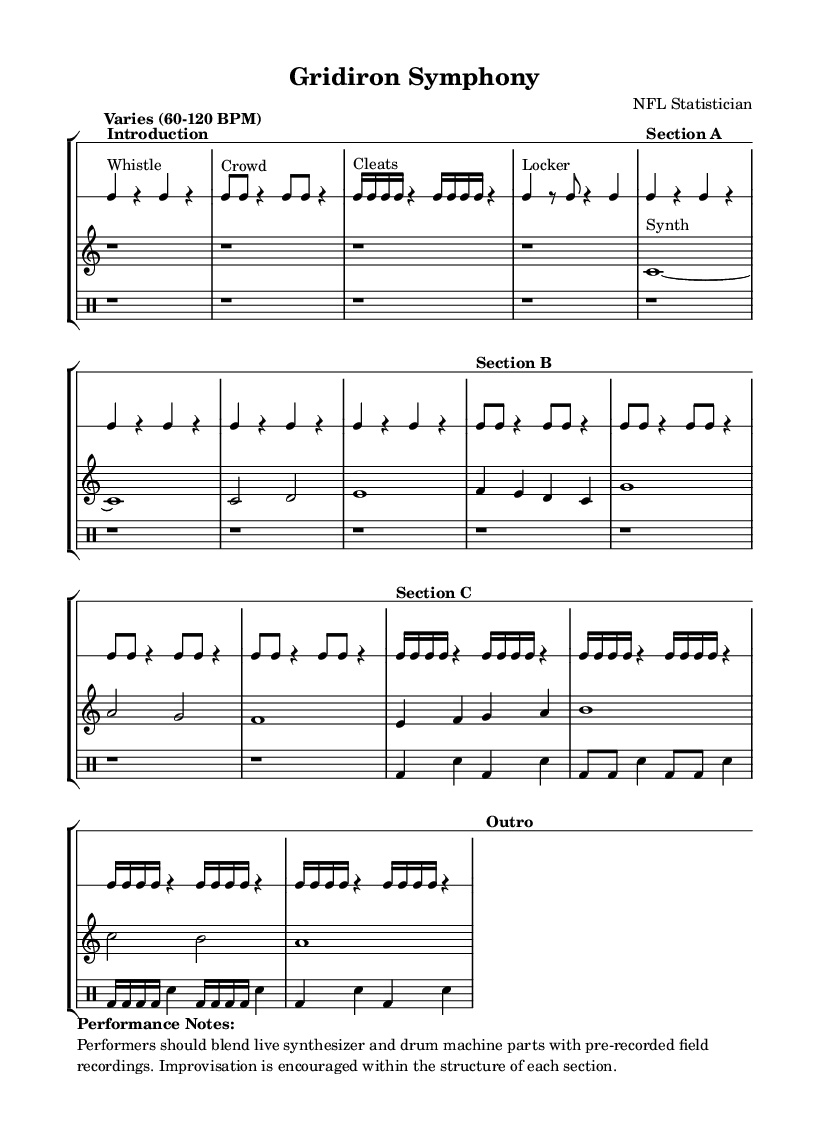What is the time signature of this piece? The time signature is indicated at the beginning of the rhythmic staff as 4/4. This means there are four beats in a measure, and each beat is a quarter note.
Answer: 4/4 What is the tempo range specified in the score? The tempo is marked as "Varies (60-120 BPM)," meaning the performance speed can fluctuate within that range. This flexibility reflects the experimental nature of the piece.
Answer: 60-120 BPM What sound is associated with the rhythmic staff's notes? The rhythmic staff includes specific sounds labeled as "Whistle," "Crowd," "Cleats," "Locker," and indications for drumming (bass drum and snare). These designations suggest the specific field recordings being imitated or incorporated.
Answer: Whistle, Crowd, Cleats, Locker How many distinct sections are indicated in the score? The score features five distinct sections labeled as "Introduction," "Section A," "Section B," "Section C," and "Outro." Each section contributes to the overall structure of the composition.
Answer: Five What type of instruments are indicated for the melodic staff? The melodic staff designates the sound of a synthesizer, indicated by the text "Synth" placed above the respective notes, suggesting the electronic nature of the piece.
Answer: Synthesizer Explain the purpose of the "Performance Notes" section. The "Performance Notes" specify instructions for how the piece should be performed, emphasizing the blend of live instruments with pre-recorded sounds and encouraging improvisation. This guidance is essential for achieving the intended experimental sound.
Answer: Blend of live synthesizer and drum machine with field recordings 